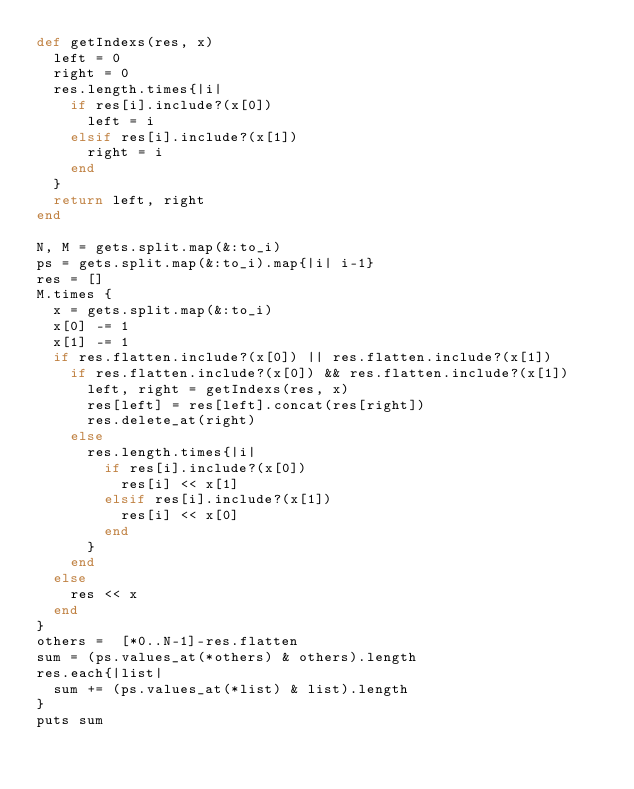Convert code to text. <code><loc_0><loc_0><loc_500><loc_500><_Ruby_>def getIndexs(res, x)
  left = 0
  right = 0
  res.length.times{|i|
    if res[i].include?(x[0]) 
      left = i
    elsif res[i].include?(x[1]) 
      right = i
    end
  }
  return left, right
end

N, M = gets.split.map(&:to_i)
ps = gets.split.map(&:to_i).map{|i| i-1}
res = []
M.times { 
  x = gets.split.map(&:to_i)
  x[0] -= 1
  x[1] -= 1
  if res.flatten.include?(x[0]) || res.flatten.include?(x[1])
    if res.flatten.include?(x[0]) && res.flatten.include?(x[1])
      left, right = getIndexs(res, x)
      res[left] = res[left].concat(res[right])
      res.delete_at(right)
    else
      res.length.times{|i|
        if res[i].include?(x[0]) 
          res[i] << x[1]
        elsif res[i].include?(x[1]) 
          res[i] << x[0]
        end
      }
    end
  else
    res << x
  end
}
others =  [*0..N-1]-res.flatten
sum = (ps.values_at(*others) & others).length
res.each{|list|
  sum += (ps.values_at(*list) & list).length
}
puts sum
</code> 